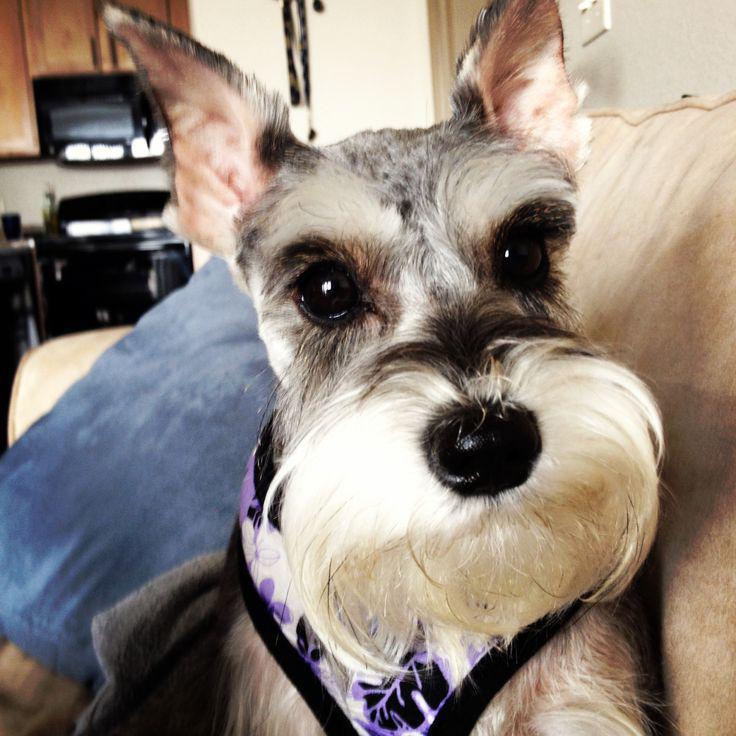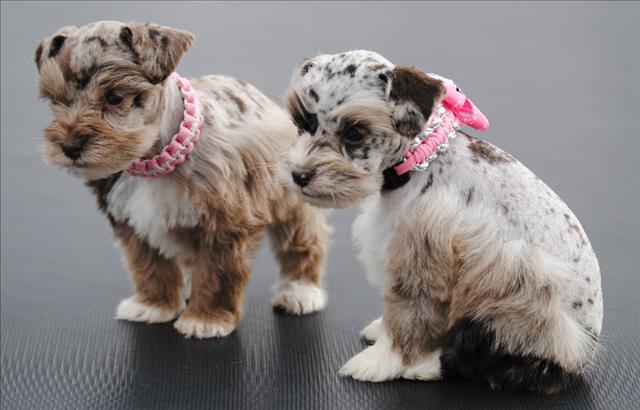The first image is the image on the left, the second image is the image on the right. For the images displayed, is the sentence "An image shows one schnauzer, which is wearing a printed bandana around its neck." factually correct? Answer yes or no. Yes. The first image is the image on the left, the second image is the image on the right. Evaluate the accuracy of this statement regarding the images: "One of the dogs is sitting in a bag.". Is it true? Answer yes or no. No. 